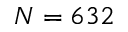Convert formula to latex. <formula><loc_0><loc_0><loc_500><loc_500>N = 6 3 2</formula> 